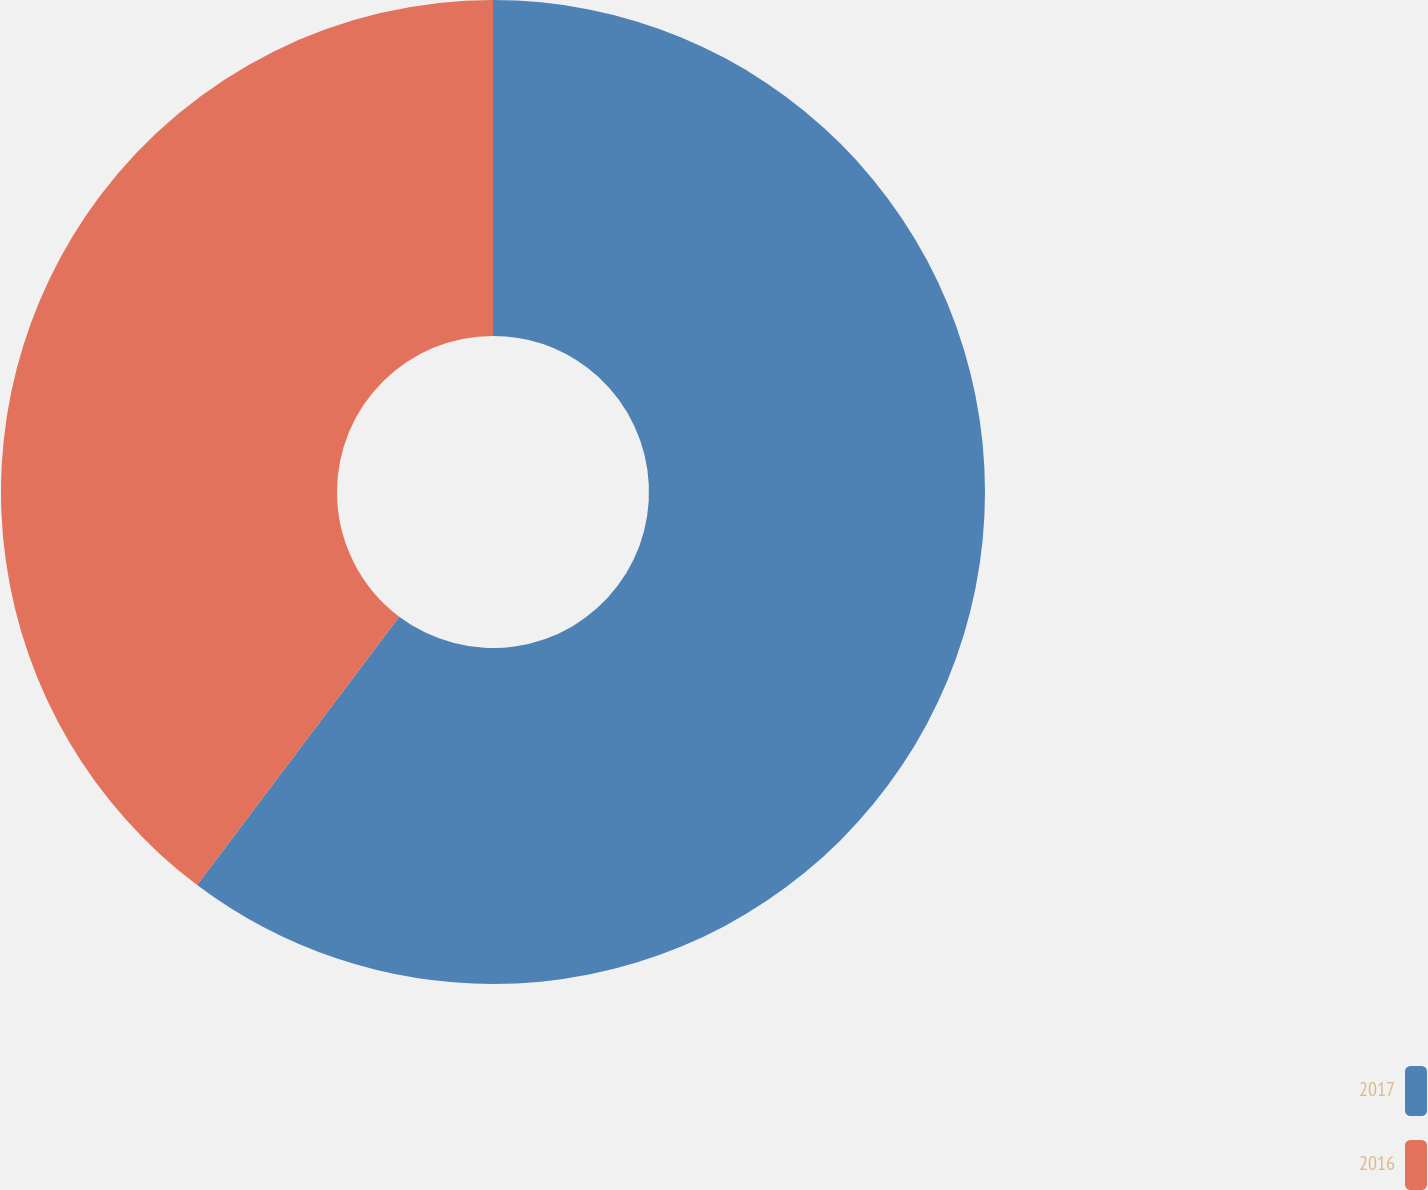<chart> <loc_0><loc_0><loc_500><loc_500><pie_chart><fcel>2017<fcel>2016<nl><fcel>60.27%<fcel>39.73%<nl></chart> 